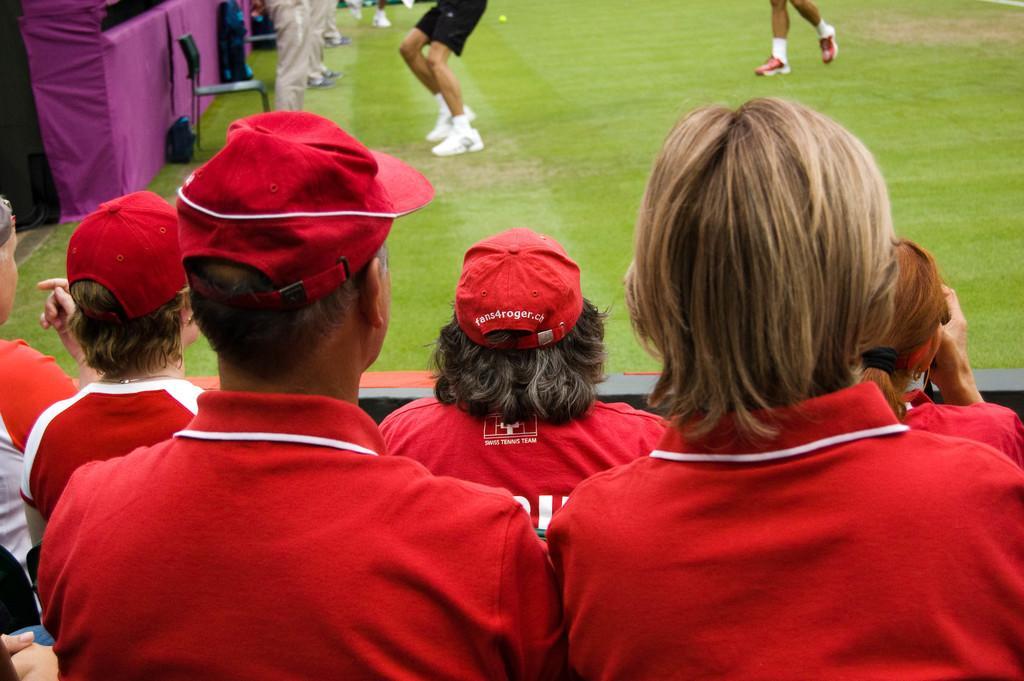How would you summarize this image in a sentence or two? In this image there are group of persons truncated towards the bottom of the image, there are persons truncated towards the left of the image, there are persons truncated towards the top of the image, there is grass, there is a chair, there are objects on the grass, there is an object truncated towards the top of the image, there is an object truncated towards the left of the image, there is an object truncated towards the right of the image, there are person truncated towards the right of the image, there is a person holding an object. 